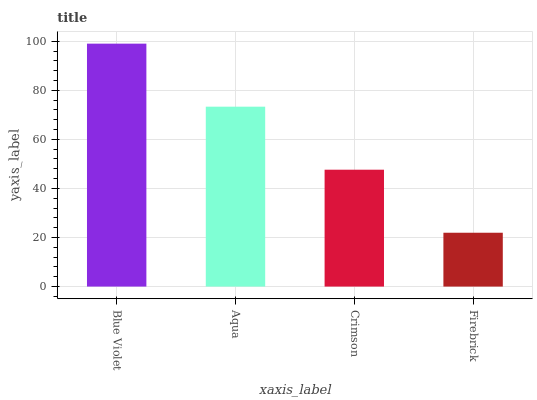Is Aqua the minimum?
Answer yes or no. No. Is Aqua the maximum?
Answer yes or no. No. Is Blue Violet greater than Aqua?
Answer yes or no. Yes. Is Aqua less than Blue Violet?
Answer yes or no. Yes. Is Aqua greater than Blue Violet?
Answer yes or no. No. Is Blue Violet less than Aqua?
Answer yes or no. No. Is Aqua the high median?
Answer yes or no. Yes. Is Crimson the low median?
Answer yes or no. Yes. Is Blue Violet the high median?
Answer yes or no. No. Is Aqua the low median?
Answer yes or no. No. 